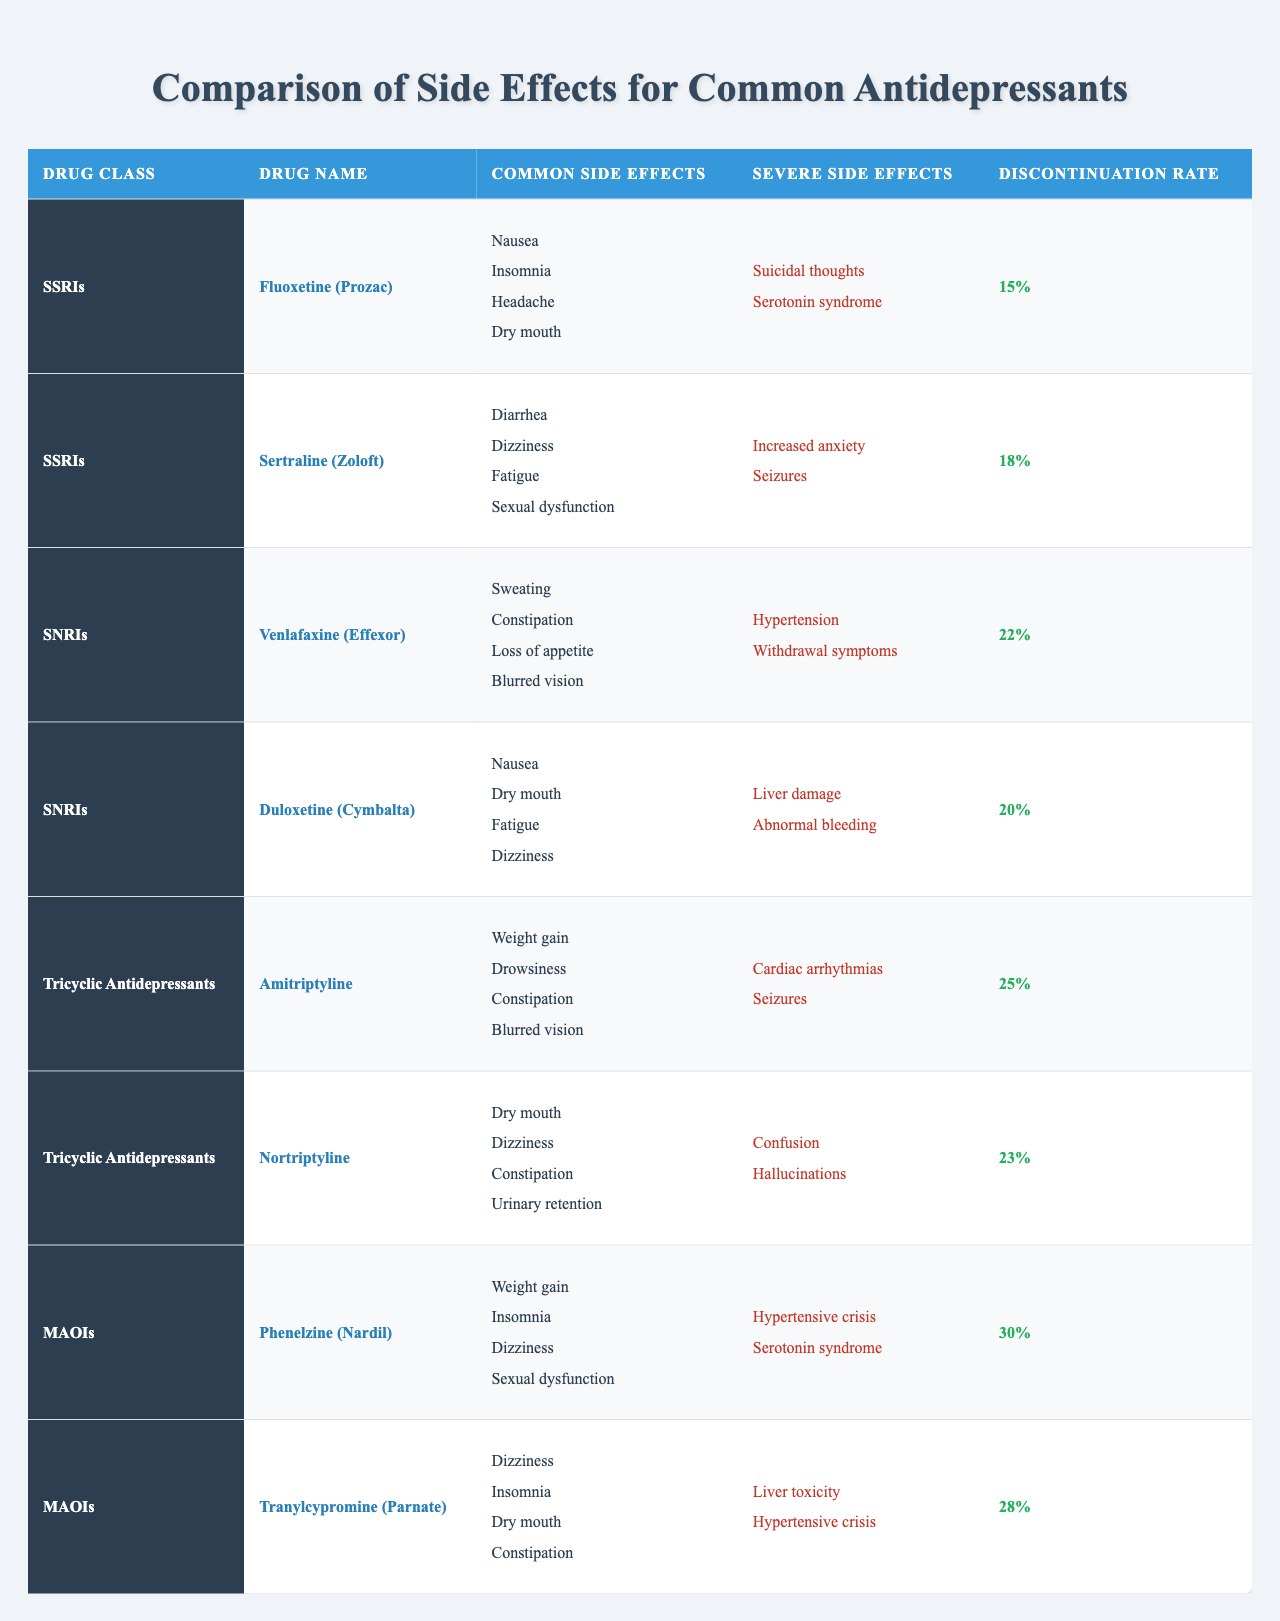What are the common side effects of Fluoxetine (Prozac)? The table lists the common side effects of Fluoxetine (Prozac) under the "Common Side Effects" section. They are Nausea, Insomnia, Headache, and Dry mouth.
Answer: Nausea, Insomnia, Headache, Dry mouth Which antidepressant class has the highest discontinuation rate? By comparing the discontinuation rates listed for each antidepressant class, Phenelzine (Nardil) from the MAOIs has a rate of 30%, which is the highest among all listed drugs.
Answer: MAOIs How many common side effects does Venlafaxine (Effexor) have? The table shows that Venlafaxine (Effexor) has four common side effects listed: Sweating, Constipation, Loss of appetite, and Blurred vision.
Answer: 4 Are there any severe side effects common to both SSRIs and SNRIs? A review of the severe side effects for both classes shows that the SSRIs have Suicidal thoughts and Serotonin syndrome, while the SNRIs have Hypertension and Withdrawal symptoms, indicating no overlap.
Answer: No Which drug has a discontinuation rate less than 20%? The discontinuation rates for the drugs in the table are all over 15%, with the lowest rates being 15% for Fluoxetine (Prozac) and 18% for Sertraline (Zoloft), so none are less than 20%.
Answer: None What is the average discontinuation rate for the Tricyclic antidepressants? The discontinuation rates for Amitriptyline and Nortriptyline are 25% and 23% respectively. Their average is (25 + 23) / 2 = 24%.
Answer: 24% Which drug class has the least severe side effects listed? By comparing the severe side effects of all drug classes, the SNRIs contain only two severe side effects for both drugs listed, while others have more. SNRIs have fewer unique severe effects.
Answer: SNRIs What is the most common side effect among the listed antidepressants? A review of all common side effects across the drugs indicates that Dry mouth is listed for both Fluoxetine and Duloxetine, making it a frequent side effect.
Answer: Dry mouth Is sexual dysfunction a common or severe side effect for any drug? In the table, sexual dysfunction is indicated as a common side effect for Sertraline and a severe side effect for Phenelzine. Thus, it appears in both categories for different drugs.
Answer: Yes Which antidepressant class has the highest number of common side effects listed across its drugs? By counting the common side effects for each drug, SSRIs have four, SNRIs have four, Tricyclic antidepressants have four, while MAOIs have four as well. So they are all equal.
Answer: All equal 